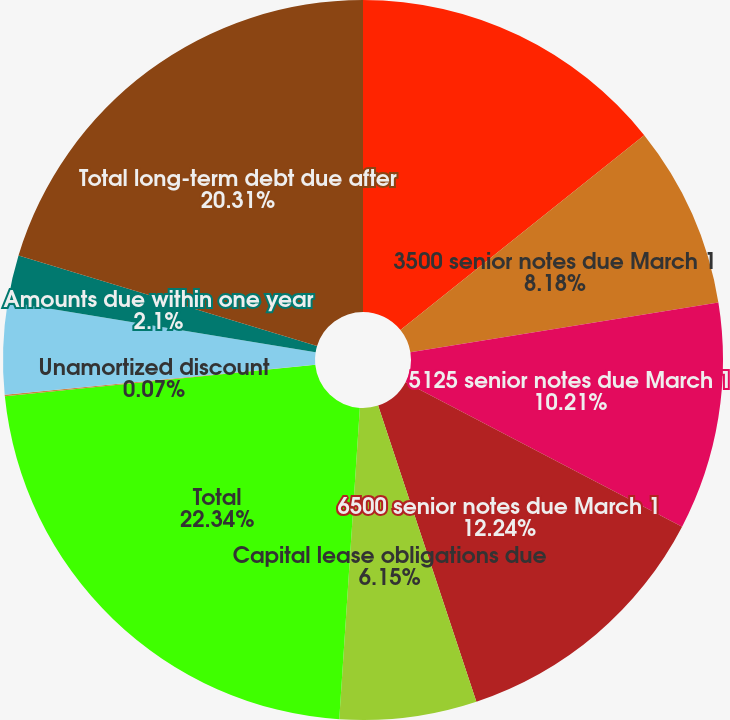<chart> <loc_0><loc_0><loc_500><loc_500><pie_chart><fcel>(In millions)<fcel>3500 senior notes due March 1<fcel>5125 senior notes due March 1<fcel>6500 senior notes due March 1<fcel>Capital lease obligations due<fcel>Total<fcel>Unamortized discount<fcel>Fair value adjustments (a)<fcel>Amounts due within one year<fcel>Total long-term debt due after<nl><fcel>14.27%<fcel>8.18%<fcel>10.21%<fcel>12.24%<fcel>6.15%<fcel>22.34%<fcel>0.07%<fcel>4.13%<fcel>2.1%<fcel>20.31%<nl></chart> 